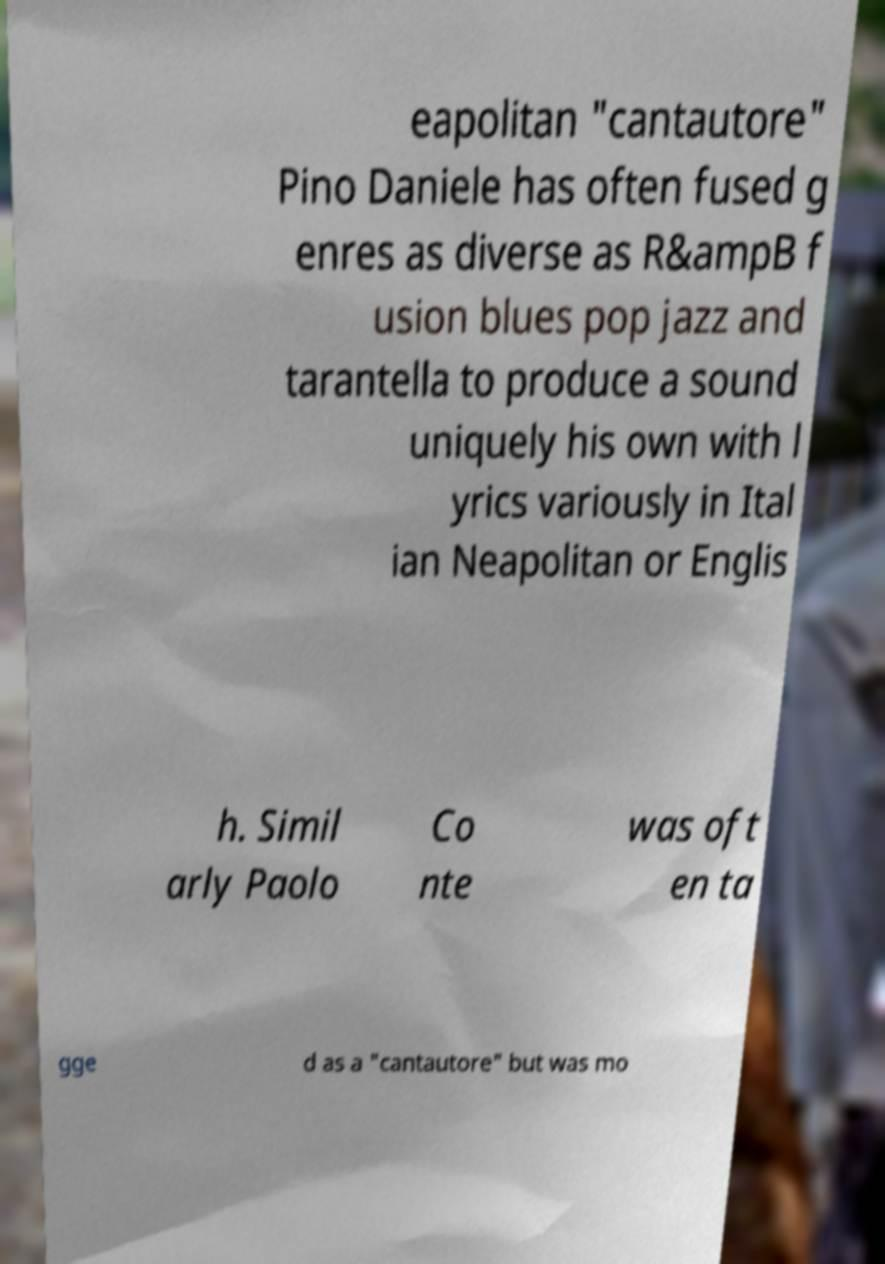For documentation purposes, I need the text within this image transcribed. Could you provide that? eapolitan "cantautore" Pino Daniele has often fused g enres as diverse as R&ampB f usion blues pop jazz and tarantella to produce a sound uniquely his own with l yrics variously in Ital ian Neapolitan or Englis h. Simil arly Paolo Co nte was oft en ta gge d as a "cantautore" but was mo 